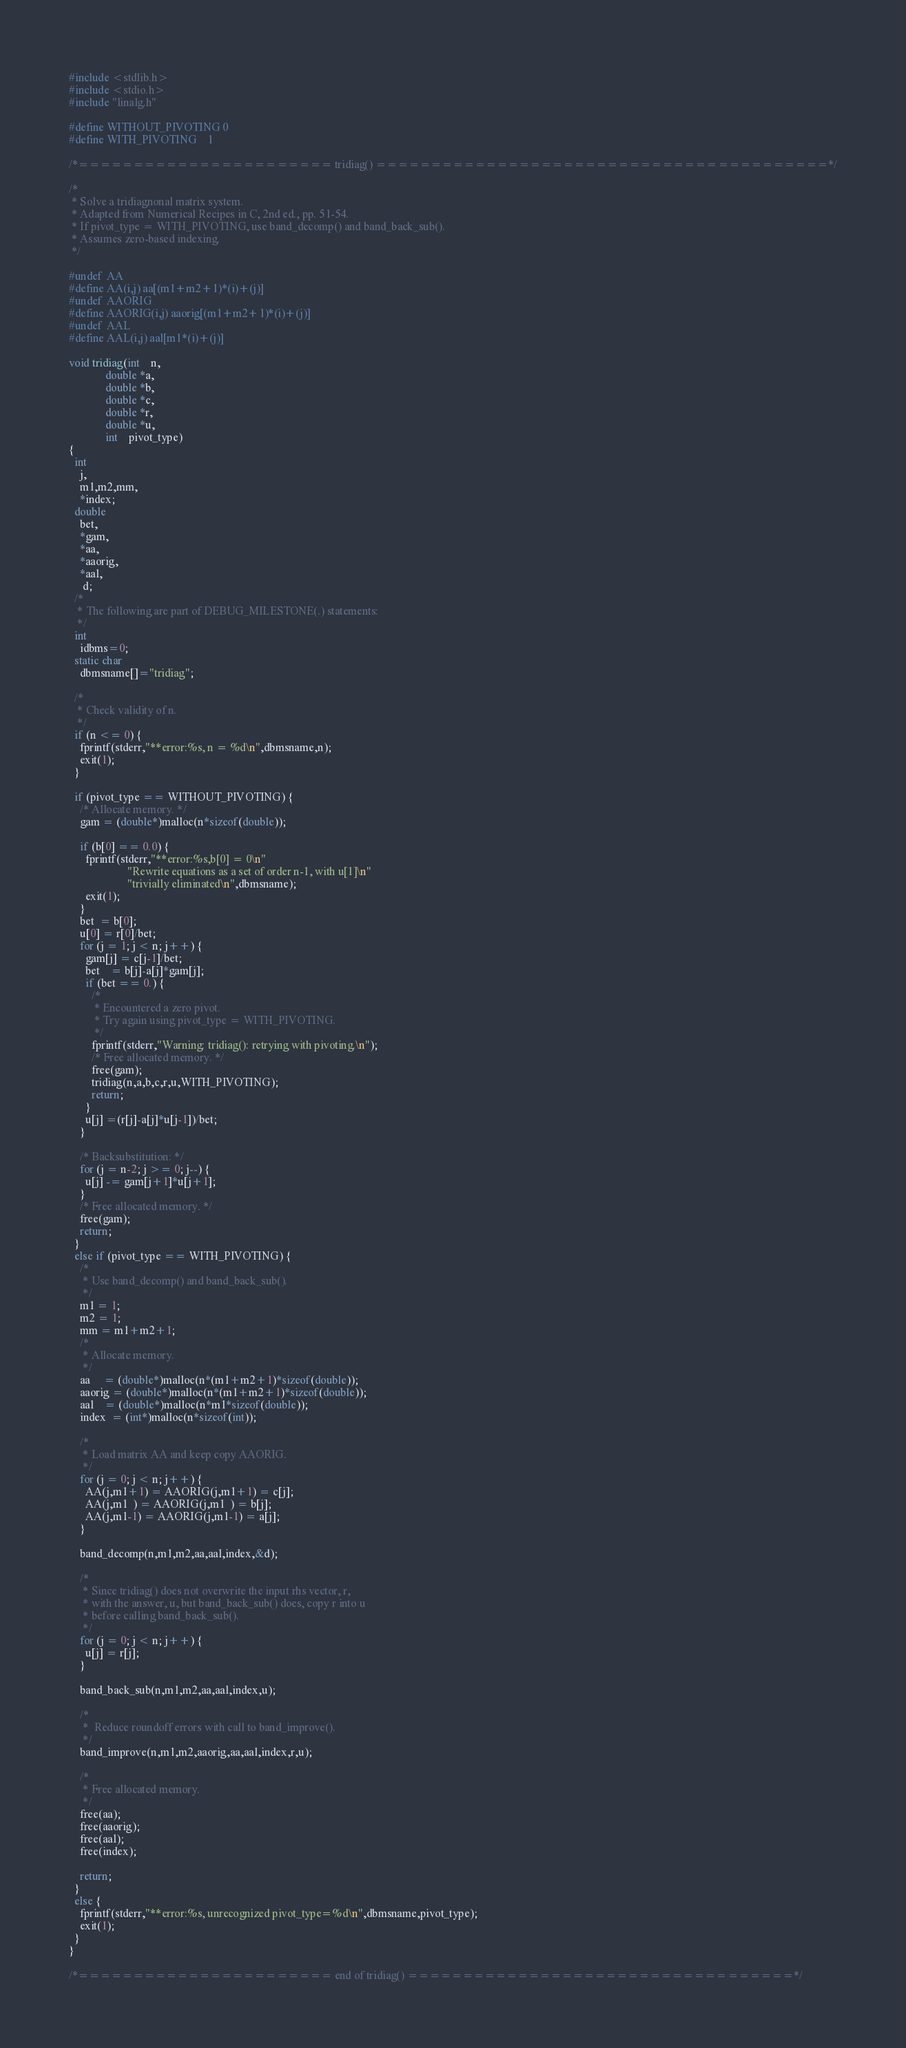Convert code to text. <code><loc_0><loc_0><loc_500><loc_500><_C_>#include <stdlib.h>
#include <stdio.h>
#include "linalg.h"

#define WITHOUT_PIVOTING 0
#define WITH_PIVOTING    1

/*======================= tridiag() =========================================*/

/*
 * Solve a tridiagnonal matrix system.
 * Adapted from Numerical Recipes in C, 2nd ed., pp. 51-54.
 * If pivot_type = WITH_PIVOTING, use band_decomp() and band_back_sub().
 * Assumes zero-based indexing.
 */

#undef  AA
#define AA(i,j) aa[(m1+m2+1)*(i)+(j)]
#undef  AAORIG
#define AAORIG(i,j) aaorig[(m1+m2+1)*(i)+(j)]
#undef  AAL
#define AAL(i,j) aal[m1*(i)+(j)]

void tridiag(int    n,
             double *a,
             double *b,
             double *c,
             double *r,
             double *u,
             int    pivot_type)
{
  int
    j,
    m1,m2,mm,
    *index;
  double
    bet,
    *gam,
    *aa,
    *aaorig,
    *aal,
     d;
  /* 
   * The following are part of DEBUG_MILESTONE(.) statements: 
   */
  int
    idbms=0;
  static char
    dbmsname[]="tridiag";

  /*
   * Check validity of n.
   */
  if (n <= 0) {
    fprintf(stderr,"**error:%s, n = %d\n",dbmsname,n);
    exit(1);
  }

  if (pivot_type == WITHOUT_PIVOTING) {
    /* Allocate memory. */
    gam = (double*)malloc(n*sizeof(double));

    if (b[0] == 0.0) {
      fprintf(stderr,"**error:%s,b[0] = 0\n"
                     "Rewrite equations as a set of order n-1, with u[1]\n"
                     "trivially eliminated\n",dbmsname);
      exit(1);
    }
    bet  = b[0];
    u[0] = r[0]/bet;
    for (j = 1; j < n; j++) {
      gam[j] = c[j-1]/bet;
      bet    = b[j]-a[j]*gam[j];
      if (bet == 0.) {
        /* 
         * Encountered a zero pivot. 
         * Try again using pivot_type = WITH_PIVOTING.
         */
        fprintf(stderr,"Warning: tridiag(): retrying with pivoting.\n");
        /* Free allocated memory. */
        free(gam);
        tridiag(n,a,b,c,r,u,WITH_PIVOTING);
        return;
      }
      u[j] =(r[j]-a[j]*u[j-1])/bet;
    }

    /* Backsubstitution: */
    for (j = n-2; j >= 0; j--) {
      u[j] -= gam[j+1]*u[j+1];
    }
    /* Free allocated memory. */
    free(gam);
    return;
  }
  else if (pivot_type == WITH_PIVOTING) {
    /*
     * Use band_decomp() and band_back_sub().
     */
    m1 = 1;
    m2 = 1;
    mm = m1+m2+1;
    /*
     * Allocate memory.
     */
    aa     = (double*)malloc(n*(m1+m2+1)*sizeof(double));
    aaorig = (double*)malloc(n*(m1+m2+1)*sizeof(double));
    aal    = (double*)malloc(n*m1*sizeof(double));
    index  = (int*)malloc(n*sizeof(int));

    /*
     * Load matrix AA and keep copy AAORIG.
     */
    for (j = 0; j < n; j++) {
      AA(j,m1+1) = AAORIG(j,m1+1) = c[j];
      AA(j,m1  ) = AAORIG(j,m1  ) = b[j];
      AA(j,m1-1) = AAORIG(j,m1-1) = a[j];
    }
    
    band_decomp(n,m1,m2,aa,aal,index,&d);

    /* 
     * Since tridiag() does not overwrite the input rhs vector, r,
     * with the answer, u, but band_back_sub() does, copy r into u
     * before calling band_back_sub().
     */
    for (j = 0; j < n; j++) {
      u[j] = r[j];
    }

    band_back_sub(n,m1,m2,aa,aal,index,u);

    /*
     *  Reduce roundoff errors with call to band_improve().
     */
    band_improve(n,m1,m2,aaorig,aa,aal,index,r,u);

    /*
     * Free allocated memory.
     */
    free(aa);
    free(aaorig);
    free(aal);
    free(index);

    return;
  }
  else {
    fprintf(stderr,"**error:%s, unrecognized pivot_type=%d\n",dbmsname,pivot_type);
    exit(1);
  }
}

/*======================= end of tridiag() ===================================*/
</code> 